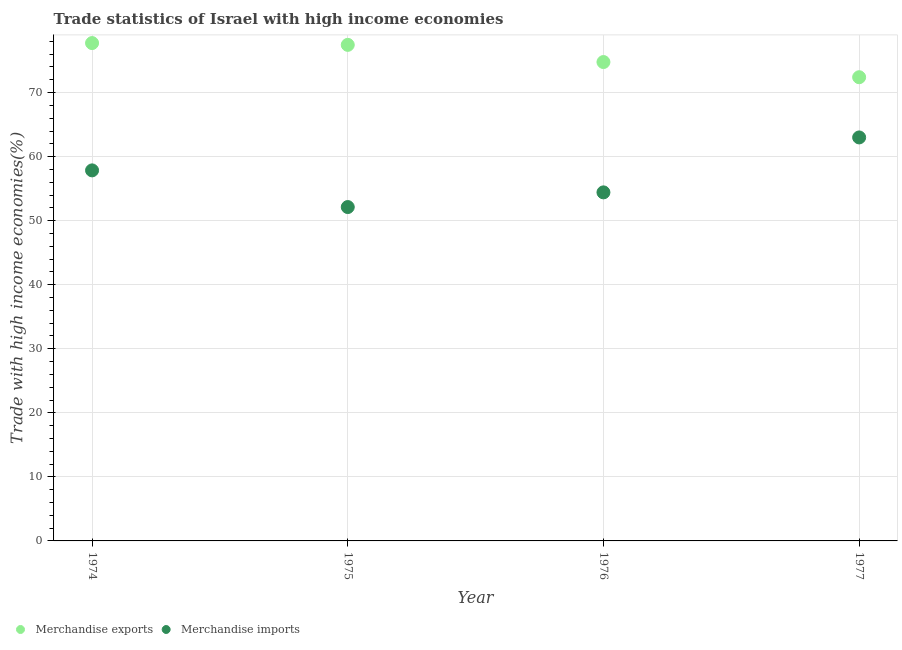How many different coloured dotlines are there?
Give a very brief answer. 2. What is the merchandise exports in 1975?
Offer a very short reply. 77.45. Across all years, what is the maximum merchandise imports?
Your response must be concise. 63. Across all years, what is the minimum merchandise imports?
Keep it short and to the point. 52.13. In which year was the merchandise imports maximum?
Your response must be concise. 1977. In which year was the merchandise exports minimum?
Your answer should be very brief. 1977. What is the total merchandise imports in the graph?
Give a very brief answer. 227.4. What is the difference between the merchandise exports in 1974 and that in 1975?
Ensure brevity in your answer.  0.28. What is the difference between the merchandise imports in 1975 and the merchandise exports in 1977?
Give a very brief answer. -20.27. What is the average merchandise exports per year?
Ensure brevity in your answer.  75.59. In the year 1976, what is the difference between the merchandise exports and merchandise imports?
Give a very brief answer. 20.35. In how many years, is the merchandise exports greater than 52 %?
Your answer should be compact. 4. What is the ratio of the merchandise imports in 1974 to that in 1976?
Keep it short and to the point. 1.06. What is the difference between the highest and the second highest merchandise exports?
Keep it short and to the point. 0.28. What is the difference between the highest and the lowest merchandise exports?
Your answer should be very brief. 5.33. Is the sum of the merchandise exports in 1976 and 1977 greater than the maximum merchandise imports across all years?
Your answer should be very brief. Yes. Is the merchandise imports strictly greater than the merchandise exports over the years?
Your response must be concise. No. Is the merchandise exports strictly less than the merchandise imports over the years?
Keep it short and to the point. No. How many years are there in the graph?
Ensure brevity in your answer.  4. What is the difference between two consecutive major ticks on the Y-axis?
Your answer should be very brief. 10. Are the values on the major ticks of Y-axis written in scientific E-notation?
Offer a very short reply. No. Does the graph contain any zero values?
Provide a short and direct response. No. What is the title of the graph?
Offer a very short reply. Trade statistics of Israel with high income economies. Does "Electricity" appear as one of the legend labels in the graph?
Offer a terse response. No. What is the label or title of the Y-axis?
Provide a succinct answer. Trade with high income economies(%). What is the Trade with high income economies(%) of Merchandise exports in 1974?
Your answer should be very brief. 77.73. What is the Trade with high income economies(%) in Merchandise imports in 1974?
Your answer should be very brief. 57.86. What is the Trade with high income economies(%) of Merchandise exports in 1975?
Provide a succinct answer. 77.45. What is the Trade with high income economies(%) of Merchandise imports in 1975?
Your answer should be compact. 52.13. What is the Trade with high income economies(%) of Merchandise exports in 1976?
Keep it short and to the point. 74.77. What is the Trade with high income economies(%) of Merchandise imports in 1976?
Provide a succinct answer. 54.42. What is the Trade with high income economies(%) of Merchandise exports in 1977?
Your response must be concise. 72.4. What is the Trade with high income economies(%) of Merchandise imports in 1977?
Keep it short and to the point. 63. Across all years, what is the maximum Trade with high income economies(%) in Merchandise exports?
Provide a short and direct response. 77.73. Across all years, what is the maximum Trade with high income economies(%) of Merchandise imports?
Provide a succinct answer. 63. Across all years, what is the minimum Trade with high income economies(%) of Merchandise exports?
Ensure brevity in your answer.  72.4. Across all years, what is the minimum Trade with high income economies(%) of Merchandise imports?
Offer a terse response. 52.13. What is the total Trade with high income economies(%) in Merchandise exports in the graph?
Make the answer very short. 302.35. What is the total Trade with high income economies(%) of Merchandise imports in the graph?
Your response must be concise. 227.4. What is the difference between the Trade with high income economies(%) in Merchandise exports in 1974 and that in 1975?
Offer a terse response. 0.28. What is the difference between the Trade with high income economies(%) of Merchandise imports in 1974 and that in 1975?
Your response must be concise. 5.73. What is the difference between the Trade with high income economies(%) in Merchandise exports in 1974 and that in 1976?
Ensure brevity in your answer.  2.96. What is the difference between the Trade with high income economies(%) of Merchandise imports in 1974 and that in 1976?
Provide a short and direct response. 3.43. What is the difference between the Trade with high income economies(%) of Merchandise exports in 1974 and that in 1977?
Your answer should be compact. 5.33. What is the difference between the Trade with high income economies(%) in Merchandise imports in 1974 and that in 1977?
Make the answer very short. -5.14. What is the difference between the Trade with high income economies(%) in Merchandise exports in 1975 and that in 1976?
Provide a succinct answer. 2.68. What is the difference between the Trade with high income economies(%) in Merchandise imports in 1975 and that in 1976?
Make the answer very short. -2.29. What is the difference between the Trade with high income economies(%) of Merchandise exports in 1975 and that in 1977?
Your answer should be compact. 5.05. What is the difference between the Trade with high income economies(%) of Merchandise imports in 1975 and that in 1977?
Your answer should be compact. -10.87. What is the difference between the Trade with high income economies(%) in Merchandise exports in 1976 and that in 1977?
Your answer should be very brief. 2.37. What is the difference between the Trade with high income economies(%) of Merchandise imports in 1976 and that in 1977?
Your answer should be very brief. -8.58. What is the difference between the Trade with high income economies(%) of Merchandise exports in 1974 and the Trade with high income economies(%) of Merchandise imports in 1975?
Your answer should be very brief. 25.6. What is the difference between the Trade with high income economies(%) of Merchandise exports in 1974 and the Trade with high income economies(%) of Merchandise imports in 1976?
Ensure brevity in your answer.  23.31. What is the difference between the Trade with high income economies(%) of Merchandise exports in 1974 and the Trade with high income economies(%) of Merchandise imports in 1977?
Give a very brief answer. 14.73. What is the difference between the Trade with high income economies(%) of Merchandise exports in 1975 and the Trade with high income economies(%) of Merchandise imports in 1976?
Your answer should be very brief. 23.03. What is the difference between the Trade with high income economies(%) of Merchandise exports in 1975 and the Trade with high income economies(%) of Merchandise imports in 1977?
Your response must be concise. 14.45. What is the difference between the Trade with high income economies(%) in Merchandise exports in 1976 and the Trade with high income economies(%) in Merchandise imports in 1977?
Give a very brief answer. 11.77. What is the average Trade with high income economies(%) in Merchandise exports per year?
Offer a very short reply. 75.59. What is the average Trade with high income economies(%) in Merchandise imports per year?
Provide a succinct answer. 56.85. In the year 1974, what is the difference between the Trade with high income economies(%) of Merchandise exports and Trade with high income economies(%) of Merchandise imports?
Offer a terse response. 19.88. In the year 1975, what is the difference between the Trade with high income economies(%) in Merchandise exports and Trade with high income economies(%) in Merchandise imports?
Keep it short and to the point. 25.32. In the year 1976, what is the difference between the Trade with high income economies(%) of Merchandise exports and Trade with high income economies(%) of Merchandise imports?
Keep it short and to the point. 20.35. In the year 1977, what is the difference between the Trade with high income economies(%) in Merchandise exports and Trade with high income economies(%) in Merchandise imports?
Provide a short and direct response. 9.4. What is the ratio of the Trade with high income economies(%) in Merchandise exports in 1974 to that in 1975?
Your response must be concise. 1. What is the ratio of the Trade with high income economies(%) of Merchandise imports in 1974 to that in 1975?
Offer a very short reply. 1.11. What is the ratio of the Trade with high income economies(%) of Merchandise exports in 1974 to that in 1976?
Provide a succinct answer. 1.04. What is the ratio of the Trade with high income economies(%) of Merchandise imports in 1974 to that in 1976?
Ensure brevity in your answer.  1.06. What is the ratio of the Trade with high income economies(%) in Merchandise exports in 1974 to that in 1977?
Offer a very short reply. 1.07. What is the ratio of the Trade with high income economies(%) of Merchandise imports in 1974 to that in 1977?
Ensure brevity in your answer.  0.92. What is the ratio of the Trade with high income economies(%) in Merchandise exports in 1975 to that in 1976?
Give a very brief answer. 1.04. What is the ratio of the Trade with high income economies(%) of Merchandise imports in 1975 to that in 1976?
Offer a terse response. 0.96. What is the ratio of the Trade with high income economies(%) in Merchandise exports in 1975 to that in 1977?
Provide a short and direct response. 1.07. What is the ratio of the Trade with high income economies(%) of Merchandise imports in 1975 to that in 1977?
Keep it short and to the point. 0.83. What is the ratio of the Trade with high income economies(%) of Merchandise exports in 1976 to that in 1977?
Give a very brief answer. 1.03. What is the ratio of the Trade with high income economies(%) of Merchandise imports in 1976 to that in 1977?
Your answer should be very brief. 0.86. What is the difference between the highest and the second highest Trade with high income economies(%) in Merchandise exports?
Offer a terse response. 0.28. What is the difference between the highest and the second highest Trade with high income economies(%) in Merchandise imports?
Your answer should be very brief. 5.14. What is the difference between the highest and the lowest Trade with high income economies(%) in Merchandise exports?
Your answer should be compact. 5.33. What is the difference between the highest and the lowest Trade with high income economies(%) of Merchandise imports?
Keep it short and to the point. 10.87. 